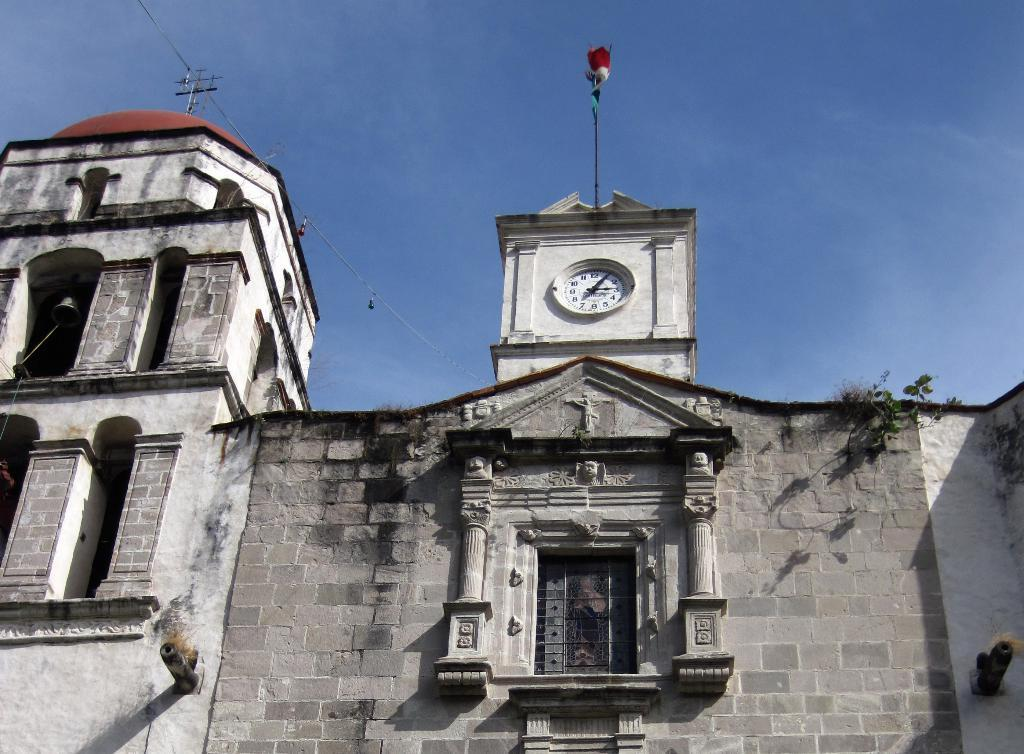What type of structure is visible in the image? There is a building with windows in the image. What feature can be seen on the building? The building has a bell. What other objects are present in the image? There are poles, a clock, and an antenna with wires in the image. Are there any plants visible in the image? Yes, there are plants in the image. What can be seen in the sky in the image? The sky is visible in the image, and it appears to be cloudy. Can you tell me how many people are exchanging cable in the image? There is no exchange of cable or any people involved in such an activity in the image. What type of cast is visible on the building in the image? There is no cast present on the building or any other part of the image. 